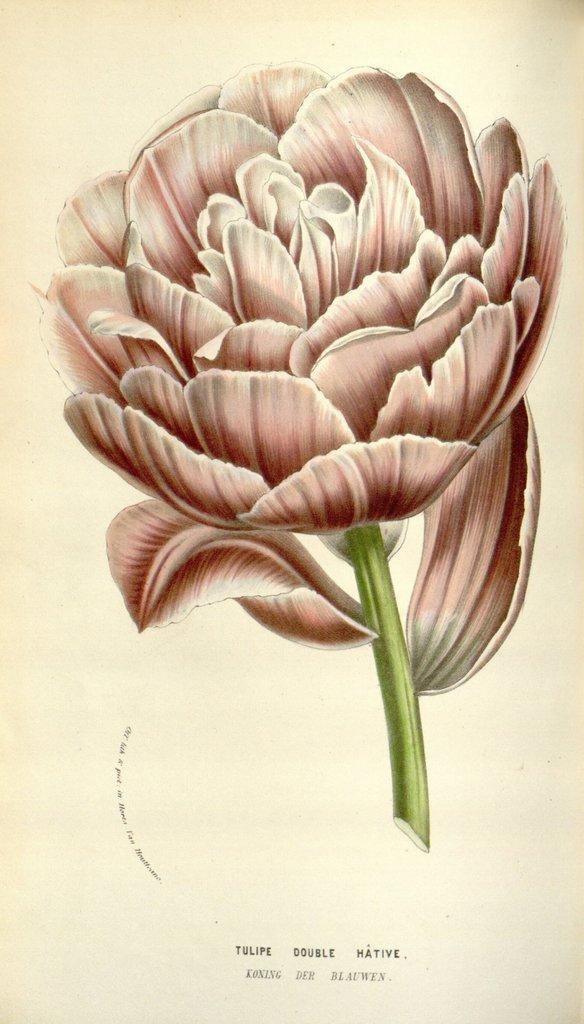In one or two sentences, can you explain what this image depicts? In this picture I can see a painted flower and its stem is in green color. 